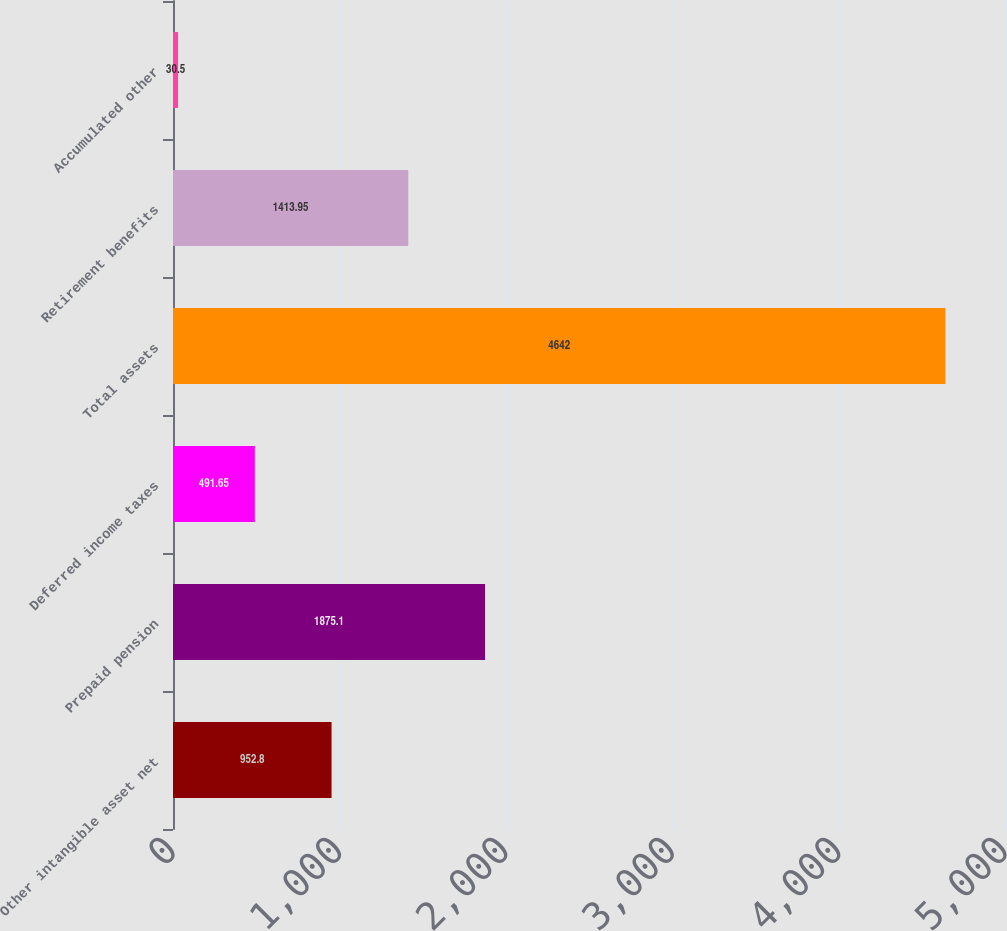Convert chart to OTSL. <chart><loc_0><loc_0><loc_500><loc_500><bar_chart><fcel>Other intangible asset net<fcel>Prepaid pension<fcel>Deferred income taxes<fcel>Total assets<fcel>Retirement benefits<fcel>Accumulated other<nl><fcel>952.8<fcel>1875.1<fcel>491.65<fcel>4642<fcel>1413.95<fcel>30.5<nl></chart> 